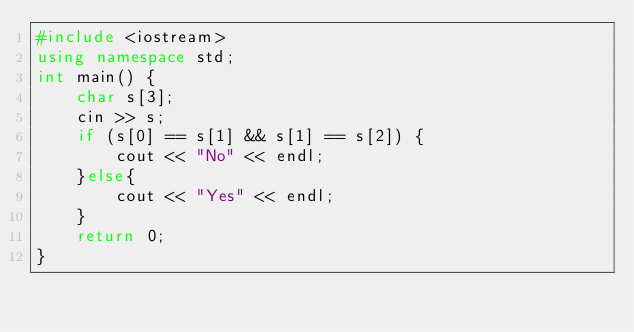<code> <loc_0><loc_0><loc_500><loc_500><_C++_>#include <iostream>
using namespace std;
int main() {
    char s[3];
    cin >> s;
    if (s[0] == s[1] && s[1] == s[2]) {
        cout << "No" << endl;
    }else{
        cout << "Yes" << endl;
    }
    return 0;
}</code> 